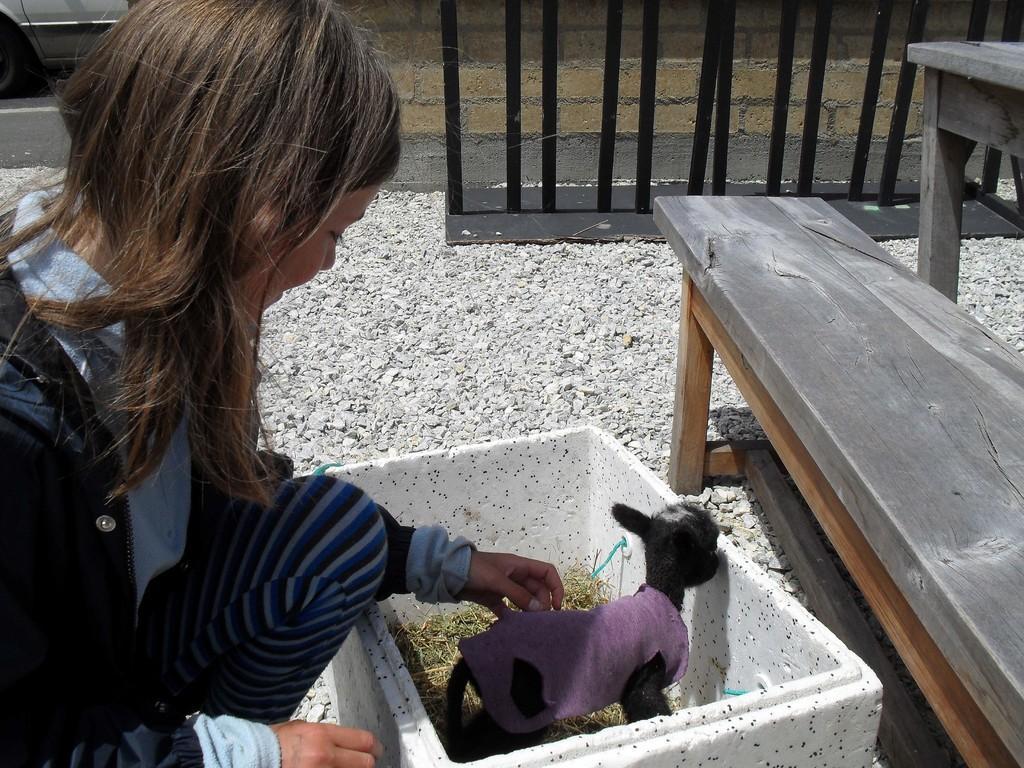How would you summarize this image in a sentence or two? In this image there is a woman sitting and holding the animal. There is an animal inside in the box and there is grass in the box. At the right side of the image there is a bench. At the back there's a wall. At the bottom there are stones and at the top there is a vehicle. 